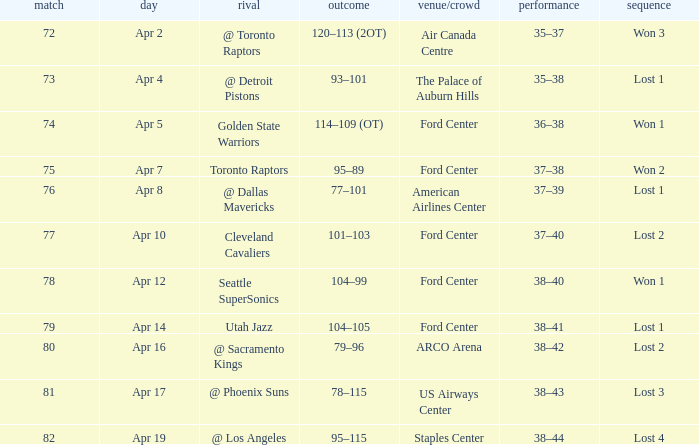What was the location when the opponent was Seattle Supersonics? Ford Center. 